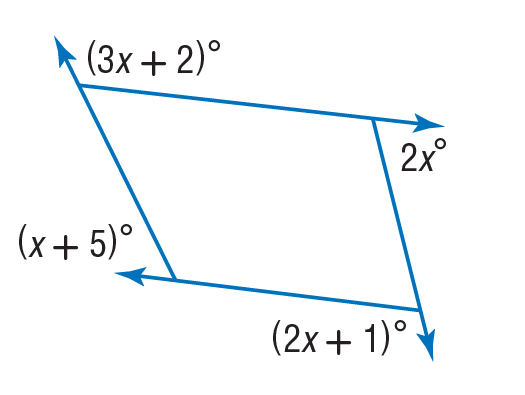Answer the mathemtical geometry problem and directly provide the correct option letter.
Question: Find the value of x in the diagram.
Choices: A: 44 B: 49 C: 88 D: 132 A 